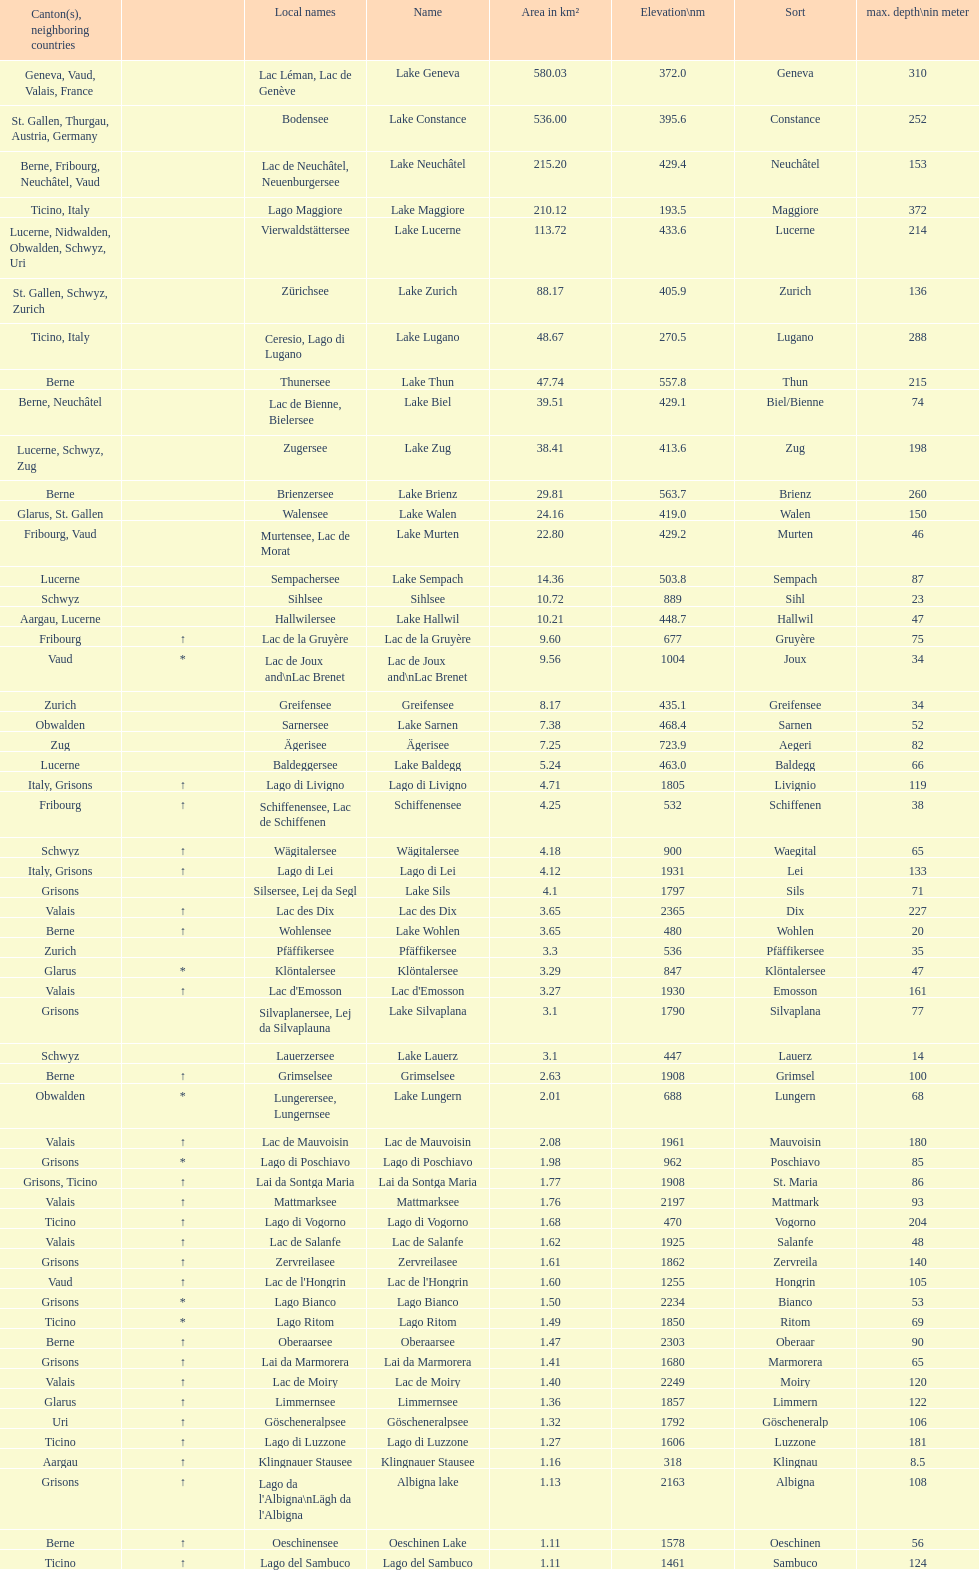Which is the only lake with a max depth of 372m? Lake Maggiore. 